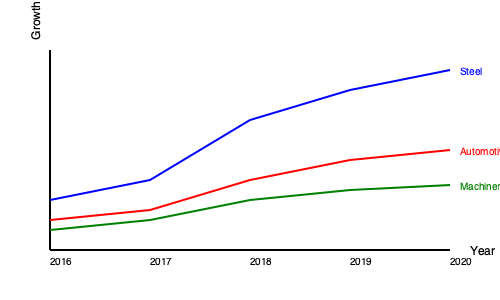Based on the line graph showing economic growth rates for three Eastern European heavy industry sectors from 2016 to 2020, which sector demonstrated the highest average growth rate over the entire period? To determine the sector with the highest average growth rate, we need to analyze the trend of each line:

1. Steel (blue line):
   - Starts around 10% in 2016
   - Ends around 36% in 2020
   - Shows a steep, consistent upward trend

2. Automotive (red line):
   - Starts around 6% in 2016
   - Ends around 20% in 2020
   - Shows a moderate upward trend

3. Machinery (green line):
   - Starts around 4% in 2016
   - Ends around 13% in 2020
   - Shows a slight upward trend

While we don't have exact numbers for each year, we can visually estimate the average growth rate by considering the starting and ending points, as well as the overall trend.

The steel sector shows the steepest incline and the highest overall growth from start to finish. It begins with the highest rate and maintains the top position throughout the period, widening its lead over time.

The automotive sector shows the second-highest growth rate, with a noticeable but less steep incline compared to steel.

The machinery sector shows the lowest growth rate, with only a slight upward trend over the five-year period.

Based on these observations, the steel sector clearly demonstrates the highest average growth rate over the entire period.
Answer: Steel 